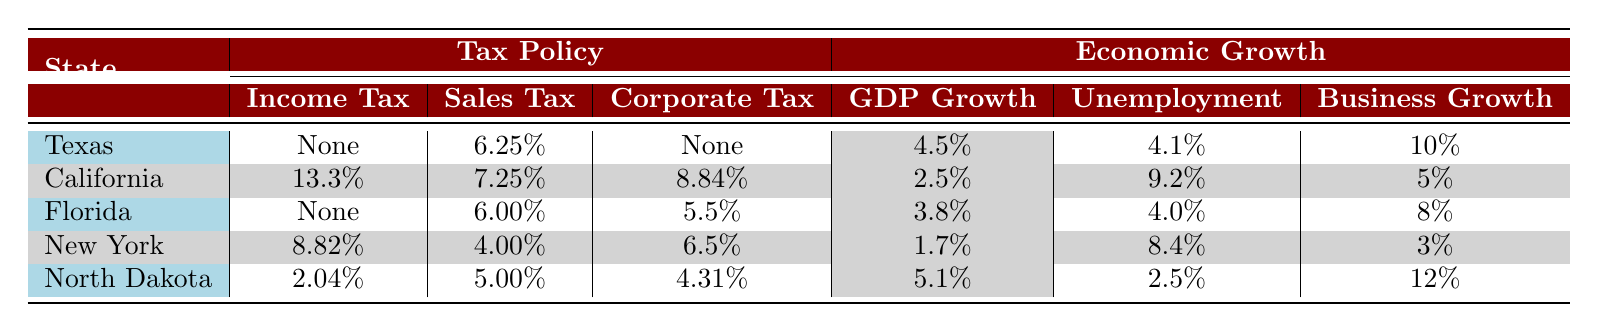What is the income tax rate in Texas? Texas has no state income tax, which is explicitly stated in the table under the tax policy column.
Answer: No state income tax Which state has the highest corporate tax rate? The table lists California with a corporate tax of 8.84%, which is higher than the corporate tax rates of the other listed states.
Answer: California What is the GDP growth rate of North Dakota? North Dakota's GDP growth rate is listed as 5.1% in the economic growth section of the table.
Answer: 5.1% How does Florida's unemployment rate compare to New York's? Florida's unemployment rate is 4.0% while New York's is 8.4%. To compare, Florida's rate is significantly lower by subtracting Florida's from New York's: 8.4% - 4.0% = 4.4%.
Answer: Florida's unemployment rate is 4.4% lower than New York's Which state has the highest business growth rate? The table shows North Dakota with a business growth rate of 12%, which is the highest value seen among all the states listed.
Answer: North Dakota Is it true that California has a lower GDP growth rate than New York? California's GDP growth rate is 2.5%, while New York's is 1.7%. Since 2.5% is greater than 1.7%, the statement is false.
Answer: No If we average the GDP growth rates of Texas, Florida, and North Dakota, what is the result? The GDP growth rates are 4.5% for Texas, 3.8% for Florida, and 5.1% for North Dakota. Summing these yields 4.5% + 3.8% + 5.1% = 13.4% and dividing by 3 gives an average of 4.47%.
Answer: 4.47% Which states have no corporate income tax? According to the table, Texas and Florida both have no corporate income tax listed under their respective tax policies.
Answer: Texas and Florida What is the difference in sales tax between California and North Dakota? California's sales tax is 7.25% and North Dakota's is 5.00%. The difference is calculated as 7.25% - 5.00% = 2.25%.
Answer: 2.25% 